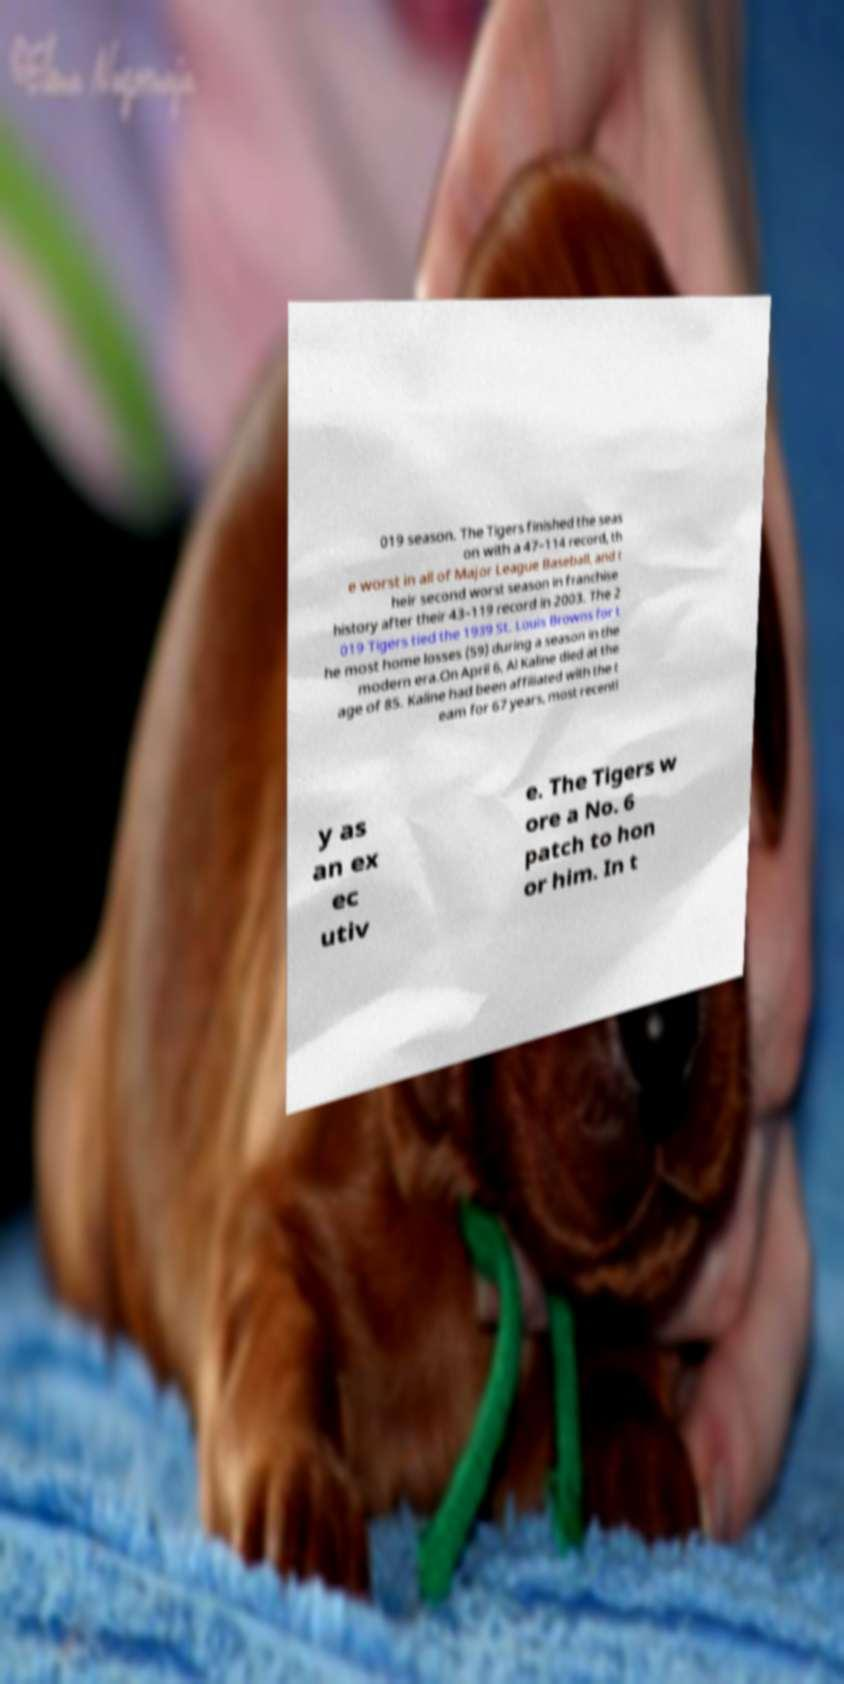For documentation purposes, I need the text within this image transcribed. Could you provide that? 019 season. The Tigers finished the seas on with a 47–114 record, th e worst in all of Major League Baseball, and t heir second worst season in franchise history after their 43–119 record in 2003. The 2 019 Tigers tied the 1939 St. Louis Browns for t he most home losses (59) during a season in the modern era.On April 6, Al Kaline died at the age of 85. Kaline had been affiliated with the t eam for 67 years, most recentl y as an ex ec utiv e. The Tigers w ore a No. 6 patch to hon or him. In t 